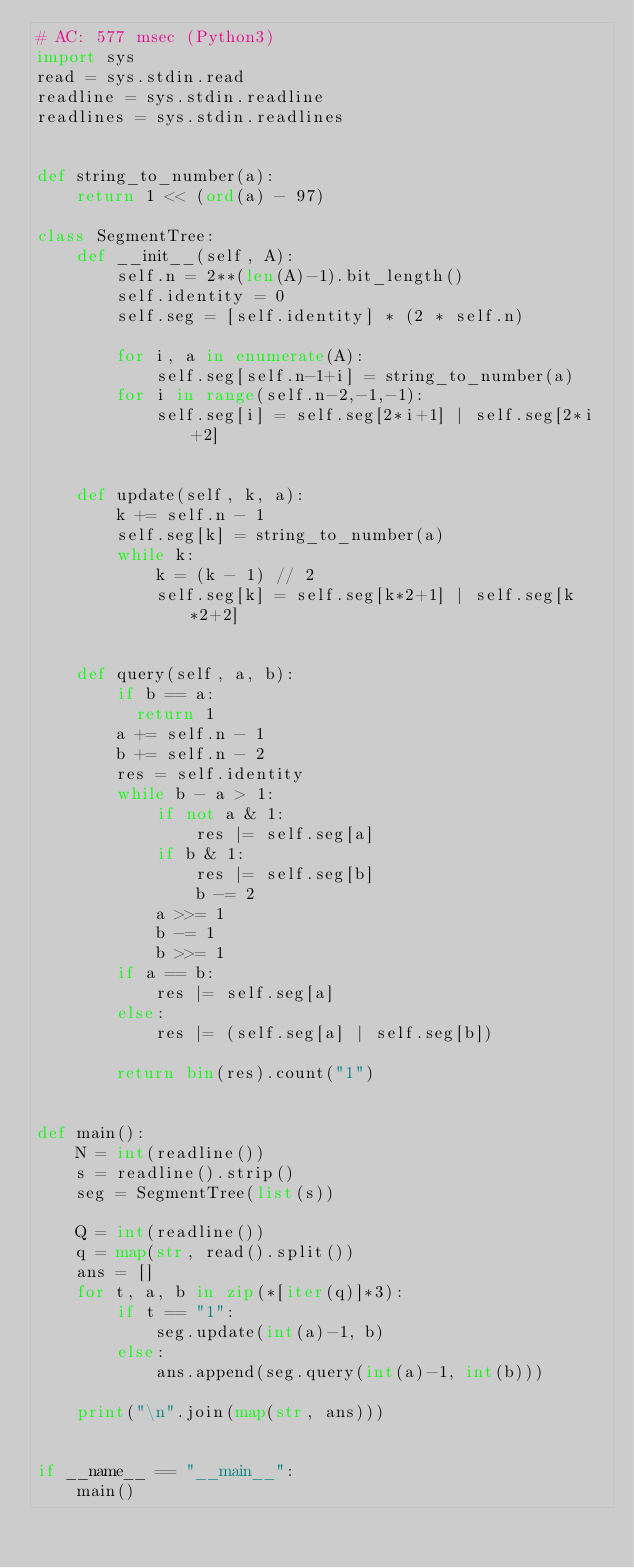Convert code to text. <code><loc_0><loc_0><loc_500><loc_500><_Python_># AC: 577 msec (Python3)
import sys
read = sys.stdin.read
readline = sys.stdin.readline
readlines = sys.stdin.readlines


def string_to_number(a):
    return 1 << (ord(a) - 97)

class SegmentTree:
    def __init__(self, A):
        self.n = 2**(len(A)-1).bit_length()
        self.identity = 0
        self.seg = [self.identity] * (2 * self.n)
        
        for i, a in enumerate(A):
            self.seg[self.n-1+i] = string_to_number(a)
        for i in range(self.n-2,-1,-1):
            self.seg[i] = self.seg[2*i+1] | self.seg[2*i+2]

            
    def update(self, k, a):
        k += self.n - 1
        self.seg[k] = string_to_number(a)
        while k:
            k = (k - 1) // 2
            self.seg[k] = self.seg[k*2+1] | self.seg[k*2+2]

            
    def query(self, a, b):
        if b == a:
        	return 1
        a += self.n - 1
        b += self.n - 2
        res = self.identity
        while b - a > 1:
            if not a & 1:
                res |= self.seg[a]
            if b & 1:
                res |= self.seg[b]
                b -= 2
            a >>= 1
            b -= 1
            b >>= 1
        if a == b:
            res |= self.seg[a]
        else:
            res |= (self.seg[a] | self.seg[b])
        
        return bin(res).count("1")


def main():
    N = int(readline())
    s = readline().strip()
    seg = SegmentTree(list(s))

    Q = int(readline())
    q = map(str, read().split())
    ans = []
    for t, a, b in zip(*[iter(q)]*3):
        if t == "1":
            seg.update(int(a)-1, b)
        else:
            ans.append(seg.query(int(a)-1, int(b)))
    
    print("\n".join(map(str, ans)))


if __name__ == "__main__":
    main()
</code> 